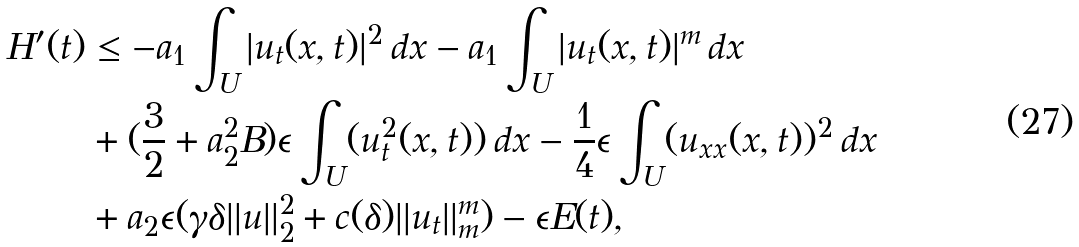Convert formula to latex. <formula><loc_0><loc_0><loc_500><loc_500>H ^ { \prime } ( t ) & \leq - a _ { 1 } \int _ { U } | u _ { t } ( x , t ) | ^ { 2 } \, d x - a _ { 1 } \int _ { U } | u _ { t } ( x , t ) | ^ { m } \, d x \\ & + ( \frac { 3 } { 2 } + a ^ { 2 } _ { 2 } B ) \epsilon \int _ { U } ( u _ { t } ^ { 2 } ( x , t ) ) \, d x - \frac { 1 } { 4 } \epsilon \int _ { U } ( u _ { x x } ( x , t ) ) ^ { 2 } \, d x \\ & + a _ { 2 } \epsilon ( \gamma \delta | | u | | ^ { 2 } _ { 2 } + c ( \delta ) | | u _ { t } | | ^ { m } _ { m } ) - \epsilon E ( t ) ,</formula> 